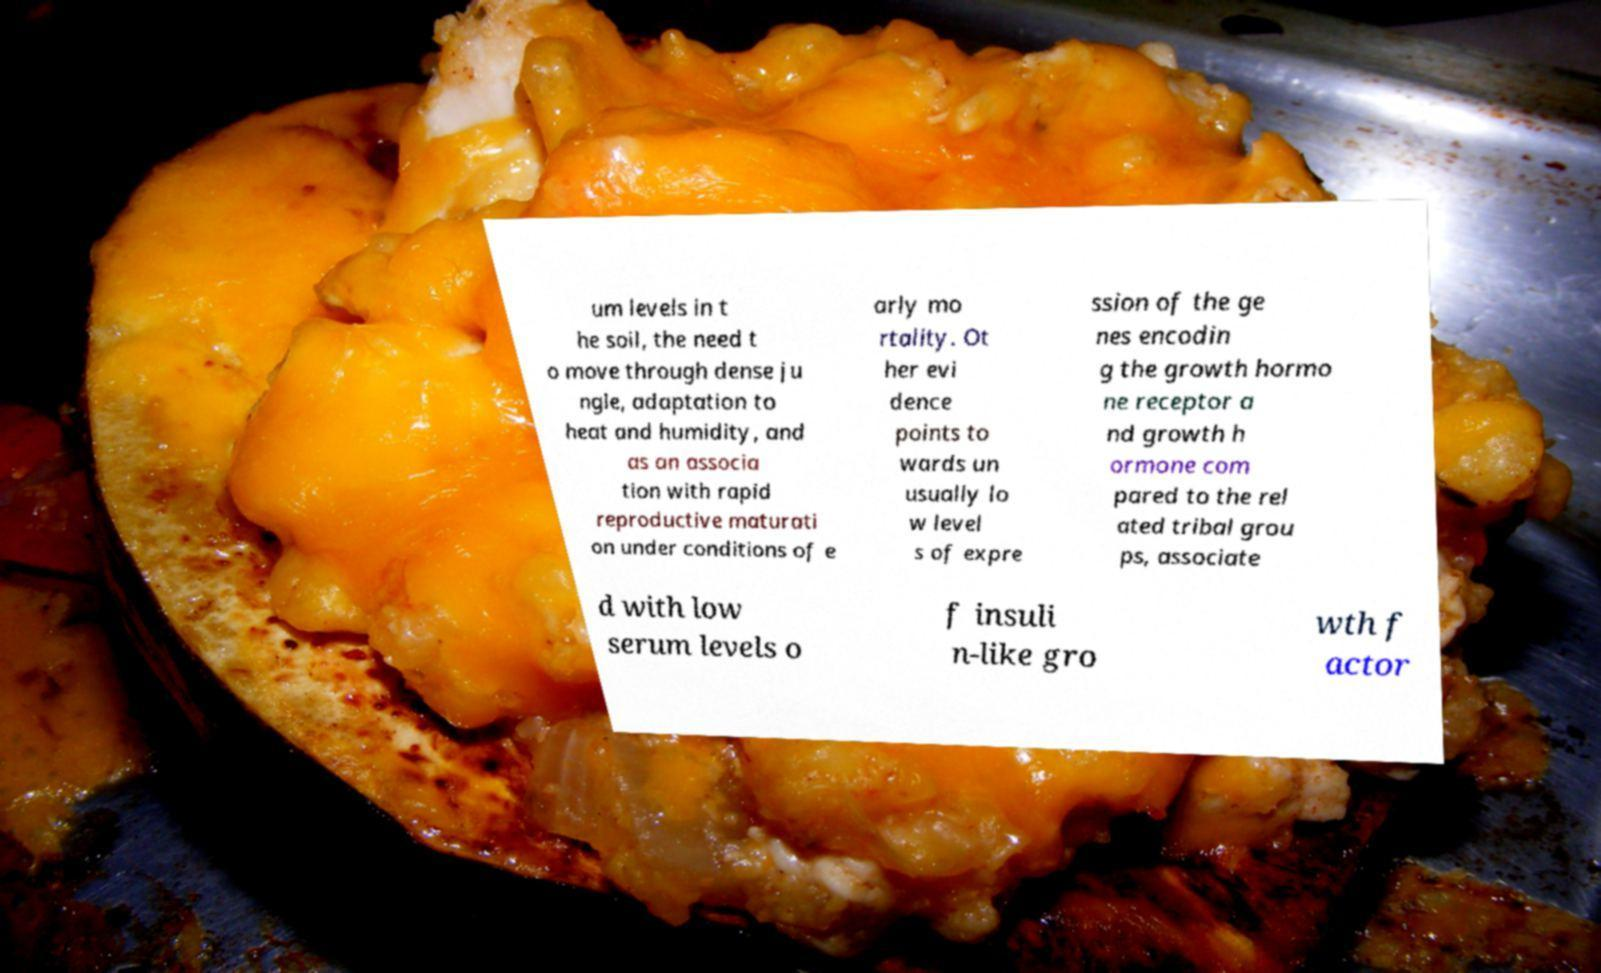Please identify and transcribe the text found in this image. um levels in t he soil, the need t o move through dense ju ngle, adaptation to heat and humidity, and as an associa tion with rapid reproductive maturati on under conditions of e arly mo rtality. Ot her evi dence points to wards un usually lo w level s of expre ssion of the ge nes encodin g the growth hormo ne receptor a nd growth h ormone com pared to the rel ated tribal grou ps, associate d with low serum levels o f insuli n-like gro wth f actor 